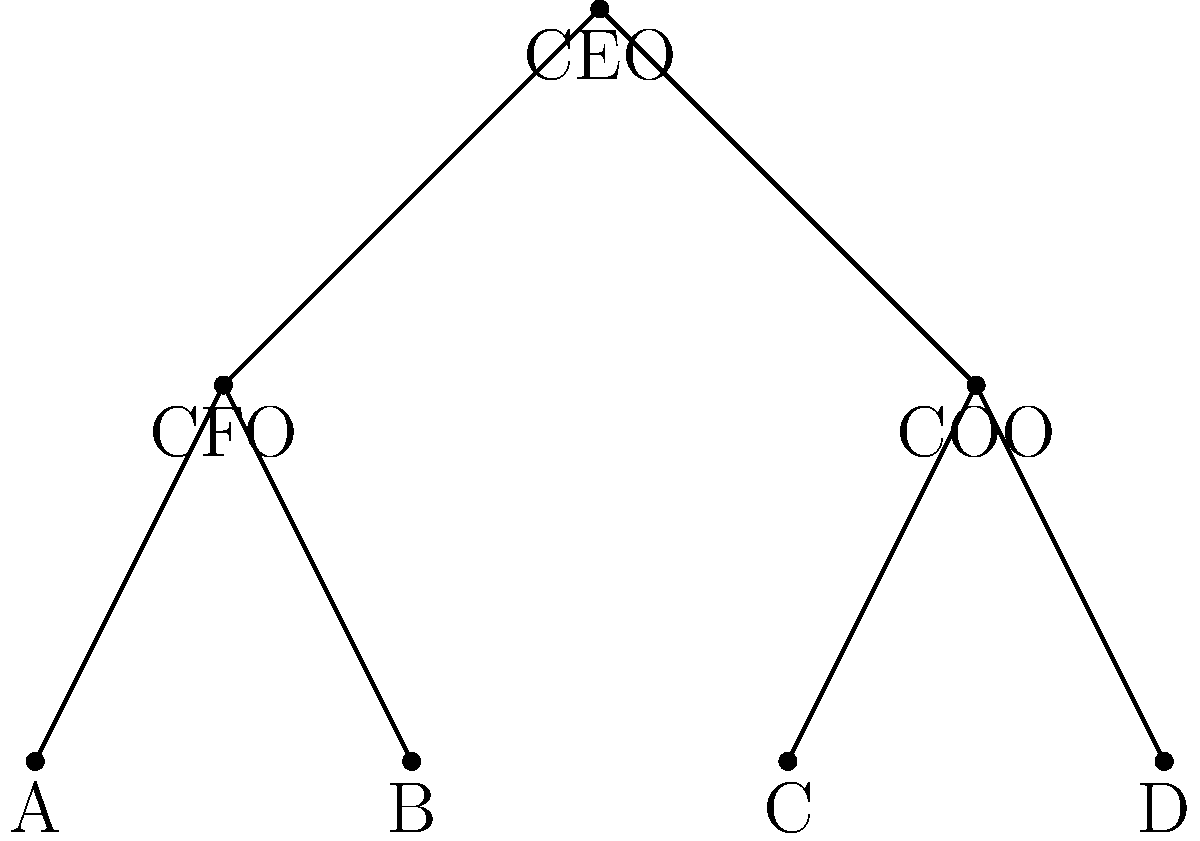Consider the organizational chart of your company shown above. If we were to apply a symmetry operation to this chart, which of the following statements is true about its symmetry group?

a) The symmetry group is isomorphic to $\mathbb{Z}_2$
b) The symmetry group is isomorphic to $S_3$
c) The symmetry group is isomorphic to $D_4$
d) The symmetry group is trivial (only identity element) To determine the symmetry group of this organizational chart, we need to analyze the possible symmetry operations:

1. First, observe that the chart has a vertical axis of symmetry through the CEO position.

2. The only non-trivial symmetry operation possible is a reflection about this vertical axis, which would swap:
   - CFO and COO
   - A and D
   - B and C

3. This reflection, along with the identity operation (doing nothing), forms a group with two elements.

4. A group with only two elements, the identity and one other element of order 2, is isomorphic to $\mathbb{Z}_2$, the cyclic group of order 2.

5. The other options can be eliminated:
   - $S_3$ has 6 elements, which is too many for this chart.
   - $D_4$ is the symmetry group of a square, which has 8 elements and includes rotations not possible here.
   - The trivial group is not correct because we have a non-trivial symmetry operation.

Therefore, the symmetry group of this organizational chart is isomorphic to $\mathbb{Z}_2$.
Answer: a) $\mathbb{Z}_2$ 